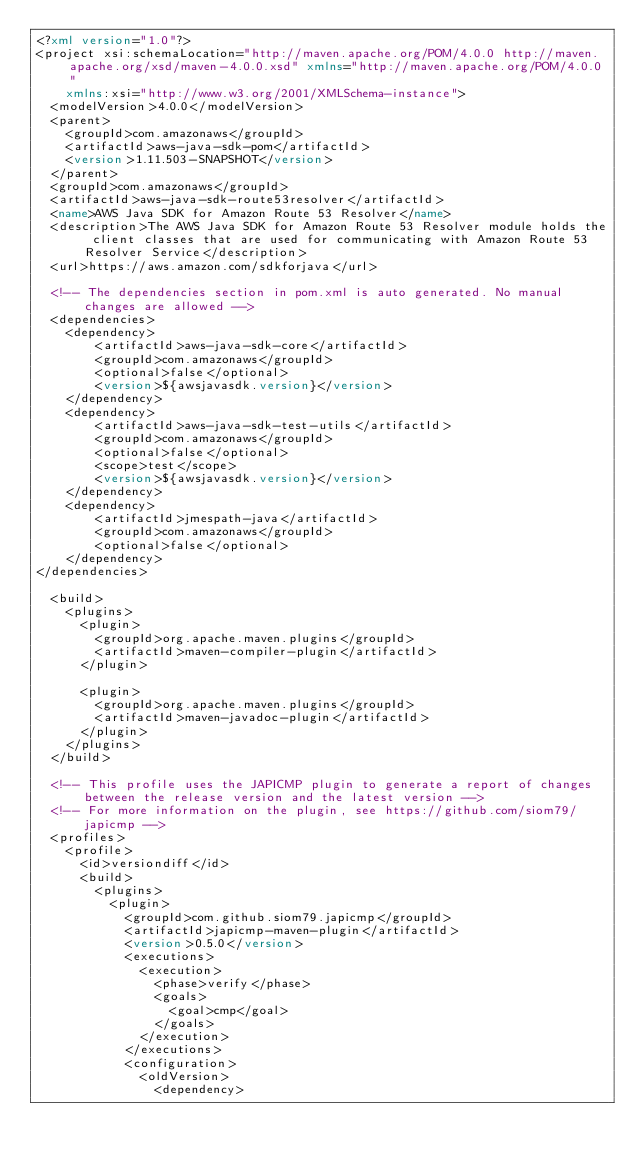<code> <loc_0><loc_0><loc_500><loc_500><_XML_><?xml version="1.0"?>
<project xsi:schemaLocation="http://maven.apache.org/POM/4.0.0 http://maven.apache.org/xsd/maven-4.0.0.xsd" xmlns="http://maven.apache.org/POM/4.0.0"
    xmlns:xsi="http://www.w3.org/2001/XMLSchema-instance">
  <modelVersion>4.0.0</modelVersion>
  <parent>
    <groupId>com.amazonaws</groupId>
    <artifactId>aws-java-sdk-pom</artifactId>
    <version>1.11.503-SNAPSHOT</version>
  </parent>
  <groupId>com.amazonaws</groupId>
  <artifactId>aws-java-sdk-route53resolver</artifactId>
  <name>AWS Java SDK for Amazon Route 53 Resolver</name>
  <description>The AWS Java SDK for Amazon Route 53 Resolver module holds the client classes that are used for communicating with Amazon Route 53 Resolver Service</description>
  <url>https://aws.amazon.com/sdkforjava</url>

  <!-- The dependencies section in pom.xml is auto generated. No manual changes are allowed -->
  <dependencies>
    <dependency>
        <artifactId>aws-java-sdk-core</artifactId>
        <groupId>com.amazonaws</groupId>
        <optional>false</optional>
        <version>${awsjavasdk.version}</version>
    </dependency>
    <dependency>
        <artifactId>aws-java-sdk-test-utils</artifactId>
        <groupId>com.amazonaws</groupId>
        <optional>false</optional>
        <scope>test</scope>
        <version>${awsjavasdk.version}</version>
    </dependency>
    <dependency>
        <artifactId>jmespath-java</artifactId>
        <groupId>com.amazonaws</groupId>
        <optional>false</optional>
    </dependency>
</dependencies>

  <build>
    <plugins>
      <plugin>
        <groupId>org.apache.maven.plugins</groupId>
        <artifactId>maven-compiler-plugin</artifactId>
      </plugin>

      <plugin>
        <groupId>org.apache.maven.plugins</groupId>
        <artifactId>maven-javadoc-plugin</artifactId>
      </plugin>
    </plugins>
  </build>

  <!-- This profile uses the JAPICMP plugin to generate a report of changes between the release version and the latest version -->
  <!-- For more information on the plugin, see https://github.com/siom79/japicmp -->
  <profiles>
    <profile>
      <id>versiondiff</id>
      <build>
        <plugins>
          <plugin>
            <groupId>com.github.siom79.japicmp</groupId>
            <artifactId>japicmp-maven-plugin</artifactId>
            <version>0.5.0</version>
            <executions>
              <execution>
                <phase>verify</phase>
                <goals>
                  <goal>cmp</goal>
                </goals>
              </execution>
            </executions>
            <configuration>
              <oldVersion>
                <dependency></code> 